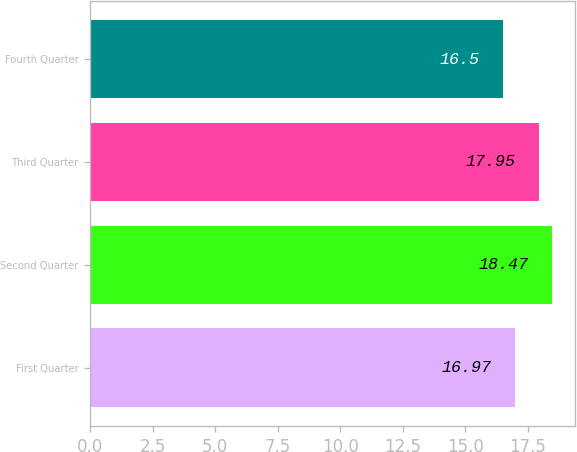Convert chart. <chart><loc_0><loc_0><loc_500><loc_500><bar_chart><fcel>First Quarter<fcel>Second Quarter<fcel>Third Quarter<fcel>Fourth Quarter<nl><fcel>16.97<fcel>18.47<fcel>17.95<fcel>16.5<nl></chart> 